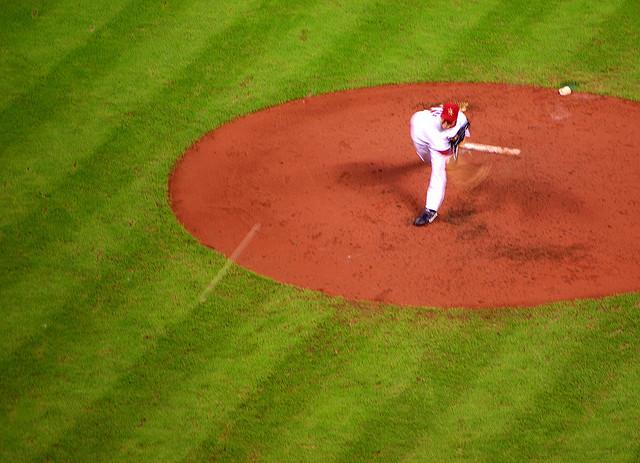Is the pitcher tired?
Concise answer only. Yes. What sport is this person playing?
Give a very brief answer. Baseball. What position does this player play?
Concise answer only. Pitcher. What color shirt does the pitcher have?
Quick response, please. White. How many people are there?
Keep it brief. 1. 